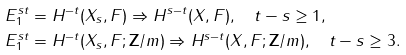Convert formula to latex. <formula><loc_0><loc_0><loc_500><loc_500>E ^ { s t } _ { 1 } & = H ^ { - t } ( X _ { s } , F ) \Rightarrow H ^ { s - t } ( X , F ) , \quad t - s \geq 1 , \\ E ^ { s t } _ { 1 } & = H ^ { - t } ( X _ { s } , F ; { \mathbf Z } / m ) \Rightarrow H ^ { s - t } ( X , F ; { \mathbf Z } / m ) , \quad t - s \geq 3 .</formula> 